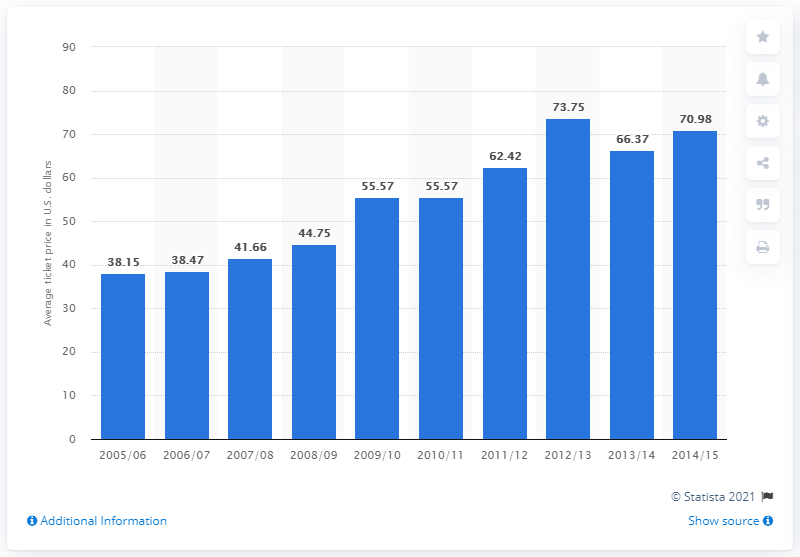Indicate a few pertinent items in this graphic. In the 2005/2006 season, the average ticket price was 38.15. 